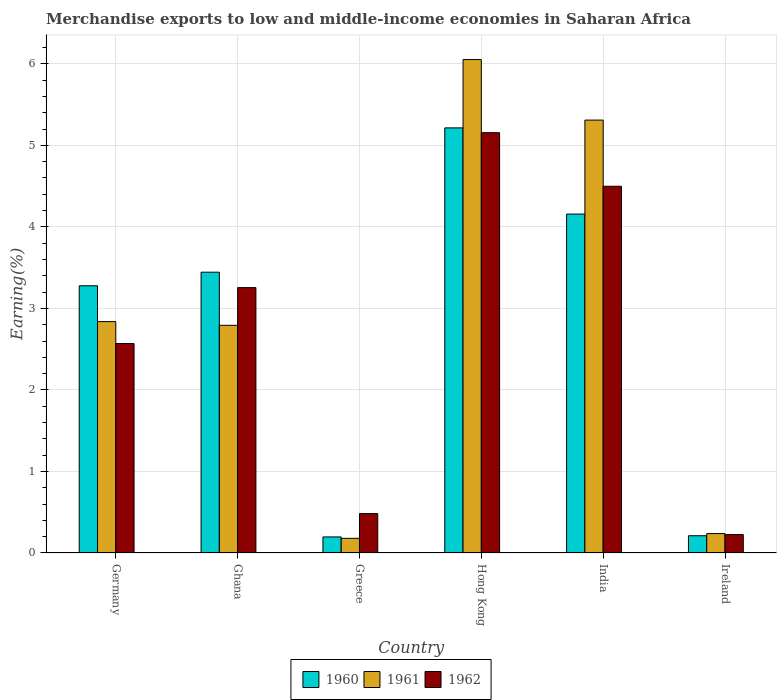How many different coloured bars are there?
Your answer should be compact. 3. How many groups of bars are there?
Ensure brevity in your answer.  6. Are the number of bars per tick equal to the number of legend labels?
Offer a very short reply. Yes. Are the number of bars on each tick of the X-axis equal?
Ensure brevity in your answer.  Yes. What is the label of the 3rd group of bars from the left?
Give a very brief answer. Greece. In how many cases, is the number of bars for a given country not equal to the number of legend labels?
Your response must be concise. 0. What is the percentage of amount earned from merchandise exports in 1961 in Ireland?
Make the answer very short. 0.24. Across all countries, what is the maximum percentage of amount earned from merchandise exports in 1960?
Provide a succinct answer. 5.21. Across all countries, what is the minimum percentage of amount earned from merchandise exports in 1961?
Keep it short and to the point. 0.18. In which country was the percentage of amount earned from merchandise exports in 1962 maximum?
Offer a terse response. Hong Kong. In which country was the percentage of amount earned from merchandise exports in 1962 minimum?
Keep it short and to the point. Ireland. What is the total percentage of amount earned from merchandise exports in 1960 in the graph?
Your answer should be compact. 16.5. What is the difference between the percentage of amount earned from merchandise exports in 1961 in Germany and that in Greece?
Your response must be concise. 2.66. What is the difference between the percentage of amount earned from merchandise exports in 1961 in India and the percentage of amount earned from merchandise exports in 1962 in Ghana?
Offer a very short reply. 2.05. What is the average percentage of amount earned from merchandise exports in 1960 per country?
Ensure brevity in your answer.  2.75. What is the difference between the percentage of amount earned from merchandise exports of/in 1960 and percentage of amount earned from merchandise exports of/in 1961 in Ireland?
Your answer should be very brief. -0.03. In how many countries, is the percentage of amount earned from merchandise exports in 1961 greater than 1.2 %?
Your answer should be very brief. 4. What is the ratio of the percentage of amount earned from merchandise exports in 1962 in Germany to that in India?
Make the answer very short. 0.57. Is the percentage of amount earned from merchandise exports in 1961 in Hong Kong less than that in India?
Your response must be concise. No. Is the difference between the percentage of amount earned from merchandise exports in 1960 in Greece and Ireland greater than the difference between the percentage of amount earned from merchandise exports in 1961 in Greece and Ireland?
Offer a very short reply. Yes. What is the difference between the highest and the second highest percentage of amount earned from merchandise exports in 1962?
Make the answer very short. -1.24. What is the difference between the highest and the lowest percentage of amount earned from merchandise exports in 1960?
Your answer should be very brief. 5.02. Is the sum of the percentage of amount earned from merchandise exports in 1961 in Ghana and India greater than the maximum percentage of amount earned from merchandise exports in 1960 across all countries?
Offer a very short reply. Yes. What does the 3rd bar from the left in Greece represents?
Make the answer very short. 1962. What does the 1st bar from the right in Hong Kong represents?
Ensure brevity in your answer.  1962. How many bars are there?
Keep it short and to the point. 18. What is the difference between two consecutive major ticks on the Y-axis?
Provide a succinct answer. 1. Does the graph contain any zero values?
Your response must be concise. No. How many legend labels are there?
Ensure brevity in your answer.  3. What is the title of the graph?
Your answer should be very brief. Merchandise exports to low and middle-income economies in Saharan Africa. Does "1966" appear as one of the legend labels in the graph?
Keep it short and to the point. No. What is the label or title of the X-axis?
Give a very brief answer. Country. What is the label or title of the Y-axis?
Give a very brief answer. Earning(%). What is the Earning(%) in 1960 in Germany?
Offer a very short reply. 3.28. What is the Earning(%) in 1961 in Germany?
Your answer should be very brief. 2.84. What is the Earning(%) of 1962 in Germany?
Give a very brief answer. 2.57. What is the Earning(%) in 1960 in Ghana?
Provide a succinct answer. 3.44. What is the Earning(%) of 1961 in Ghana?
Offer a terse response. 2.79. What is the Earning(%) in 1962 in Ghana?
Make the answer very short. 3.25. What is the Earning(%) in 1960 in Greece?
Provide a succinct answer. 0.2. What is the Earning(%) in 1961 in Greece?
Your answer should be compact. 0.18. What is the Earning(%) in 1962 in Greece?
Give a very brief answer. 0.48. What is the Earning(%) in 1960 in Hong Kong?
Your answer should be very brief. 5.21. What is the Earning(%) of 1961 in Hong Kong?
Keep it short and to the point. 6.05. What is the Earning(%) of 1962 in Hong Kong?
Ensure brevity in your answer.  5.16. What is the Earning(%) of 1960 in India?
Your response must be concise. 4.16. What is the Earning(%) of 1961 in India?
Keep it short and to the point. 5.31. What is the Earning(%) in 1962 in India?
Offer a very short reply. 4.5. What is the Earning(%) of 1960 in Ireland?
Keep it short and to the point. 0.21. What is the Earning(%) of 1961 in Ireland?
Ensure brevity in your answer.  0.24. What is the Earning(%) in 1962 in Ireland?
Your response must be concise. 0.23. Across all countries, what is the maximum Earning(%) in 1960?
Your response must be concise. 5.21. Across all countries, what is the maximum Earning(%) of 1961?
Make the answer very short. 6.05. Across all countries, what is the maximum Earning(%) of 1962?
Provide a succinct answer. 5.16. Across all countries, what is the minimum Earning(%) of 1960?
Offer a terse response. 0.2. Across all countries, what is the minimum Earning(%) of 1961?
Provide a short and direct response. 0.18. Across all countries, what is the minimum Earning(%) in 1962?
Keep it short and to the point. 0.23. What is the total Earning(%) in 1960 in the graph?
Provide a short and direct response. 16.5. What is the total Earning(%) in 1961 in the graph?
Ensure brevity in your answer.  17.41. What is the total Earning(%) in 1962 in the graph?
Your response must be concise. 16.19. What is the difference between the Earning(%) in 1960 in Germany and that in Ghana?
Your answer should be very brief. -0.17. What is the difference between the Earning(%) in 1961 in Germany and that in Ghana?
Ensure brevity in your answer.  0.05. What is the difference between the Earning(%) of 1962 in Germany and that in Ghana?
Offer a very short reply. -0.69. What is the difference between the Earning(%) in 1960 in Germany and that in Greece?
Provide a short and direct response. 3.08. What is the difference between the Earning(%) of 1961 in Germany and that in Greece?
Provide a short and direct response. 2.66. What is the difference between the Earning(%) in 1962 in Germany and that in Greece?
Keep it short and to the point. 2.09. What is the difference between the Earning(%) of 1960 in Germany and that in Hong Kong?
Your response must be concise. -1.94. What is the difference between the Earning(%) in 1961 in Germany and that in Hong Kong?
Your answer should be compact. -3.21. What is the difference between the Earning(%) in 1962 in Germany and that in Hong Kong?
Your answer should be compact. -2.59. What is the difference between the Earning(%) in 1960 in Germany and that in India?
Ensure brevity in your answer.  -0.88. What is the difference between the Earning(%) in 1961 in Germany and that in India?
Offer a terse response. -2.47. What is the difference between the Earning(%) of 1962 in Germany and that in India?
Provide a short and direct response. -1.93. What is the difference between the Earning(%) of 1960 in Germany and that in Ireland?
Give a very brief answer. 3.07. What is the difference between the Earning(%) of 1961 in Germany and that in Ireland?
Give a very brief answer. 2.6. What is the difference between the Earning(%) in 1962 in Germany and that in Ireland?
Your answer should be very brief. 2.34. What is the difference between the Earning(%) of 1960 in Ghana and that in Greece?
Ensure brevity in your answer.  3.25. What is the difference between the Earning(%) in 1961 in Ghana and that in Greece?
Offer a terse response. 2.61. What is the difference between the Earning(%) of 1962 in Ghana and that in Greece?
Your answer should be compact. 2.77. What is the difference between the Earning(%) in 1960 in Ghana and that in Hong Kong?
Your response must be concise. -1.77. What is the difference between the Earning(%) of 1961 in Ghana and that in Hong Kong?
Give a very brief answer. -3.26. What is the difference between the Earning(%) in 1962 in Ghana and that in Hong Kong?
Provide a short and direct response. -1.9. What is the difference between the Earning(%) of 1960 in Ghana and that in India?
Offer a very short reply. -0.71. What is the difference between the Earning(%) in 1961 in Ghana and that in India?
Provide a succinct answer. -2.52. What is the difference between the Earning(%) of 1962 in Ghana and that in India?
Offer a very short reply. -1.24. What is the difference between the Earning(%) in 1960 in Ghana and that in Ireland?
Your answer should be compact. 3.23. What is the difference between the Earning(%) of 1961 in Ghana and that in Ireland?
Offer a very short reply. 2.55. What is the difference between the Earning(%) in 1962 in Ghana and that in Ireland?
Provide a short and direct response. 3.03. What is the difference between the Earning(%) of 1960 in Greece and that in Hong Kong?
Your answer should be very brief. -5.02. What is the difference between the Earning(%) in 1961 in Greece and that in Hong Kong?
Your answer should be compact. -5.87. What is the difference between the Earning(%) in 1962 in Greece and that in Hong Kong?
Your answer should be compact. -4.67. What is the difference between the Earning(%) of 1960 in Greece and that in India?
Provide a succinct answer. -3.96. What is the difference between the Earning(%) of 1961 in Greece and that in India?
Offer a terse response. -5.13. What is the difference between the Earning(%) of 1962 in Greece and that in India?
Ensure brevity in your answer.  -4.01. What is the difference between the Earning(%) in 1960 in Greece and that in Ireland?
Give a very brief answer. -0.01. What is the difference between the Earning(%) in 1961 in Greece and that in Ireland?
Your answer should be compact. -0.06. What is the difference between the Earning(%) of 1962 in Greece and that in Ireland?
Ensure brevity in your answer.  0.26. What is the difference between the Earning(%) of 1960 in Hong Kong and that in India?
Offer a very short reply. 1.06. What is the difference between the Earning(%) of 1961 in Hong Kong and that in India?
Provide a succinct answer. 0.74. What is the difference between the Earning(%) of 1962 in Hong Kong and that in India?
Offer a very short reply. 0.66. What is the difference between the Earning(%) in 1960 in Hong Kong and that in Ireland?
Your answer should be compact. 5. What is the difference between the Earning(%) in 1961 in Hong Kong and that in Ireland?
Make the answer very short. 5.81. What is the difference between the Earning(%) in 1962 in Hong Kong and that in Ireland?
Provide a succinct answer. 4.93. What is the difference between the Earning(%) in 1960 in India and that in Ireland?
Provide a succinct answer. 3.95. What is the difference between the Earning(%) of 1961 in India and that in Ireland?
Your answer should be very brief. 5.07. What is the difference between the Earning(%) of 1962 in India and that in Ireland?
Make the answer very short. 4.27. What is the difference between the Earning(%) in 1960 in Germany and the Earning(%) in 1961 in Ghana?
Provide a short and direct response. 0.48. What is the difference between the Earning(%) of 1960 in Germany and the Earning(%) of 1962 in Ghana?
Your answer should be very brief. 0.02. What is the difference between the Earning(%) of 1961 in Germany and the Earning(%) of 1962 in Ghana?
Provide a succinct answer. -0.42. What is the difference between the Earning(%) of 1960 in Germany and the Earning(%) of 1961 in Greece?
Your answer should be very brief. 3.1. What is the difference between the Earning(%) in 1960 in Germany and the Earning(%) in 1962 in Greece?
Ensure brevity in your answer.  2.79. What is the difference between the Earning(%) of 1961 in Germany and the Earning(%) of 1962 in Greece?
Provide a short and direct response. 2.35. What is the difference between the Earning(%) of 1960 in Germany and the Earning(%) of 1961 in Hong Kong?
Ensure brevity in your answer.  -2.77. What is the difference between the Earning(%) of 1960 in Germany and the Earning(%) of 1962 in Hong Kong?
Offer a terse response. -1.88. What is the difference between the Earning(%) of 1961 in Germany and the Earning(%) of 1962 in Hong Kong?
Make the answer very short. -2.32. What is the difference between the Earning(%) of 1960 in Germany and the Earning(%) of 1961 in India?
Give a very brief answer. -2.03. What is the difference between the Earning(%) in 1960 in Germany and the Earning(%) in 1962 in India?
Offer a very short reply. -1.22. What is the difference between the Earning(%) of 1961 in Germany and the Earning(%) of 1962 in India?
Keep it short and to the point. -1.66. What is the difference between the Earning(%) of 1960 in Germany and the Earning(%) of 1961 in Ireland?
Provide a short and direct response. 3.04. What is the difference between the Earning(%) of 1960 in Germany and the Earning(%) of 1962 in Ireland?
Offer a terse response. 3.05. What is the difference between the Earning(%) of 1961 in Germany and the Earning(%) of 1962 in Ireland?
Offer a very short reply. 2.61. What is the difference between the Earning(%) of 1960 in Ghana and the Earning(%) of 1961 in Greece?
Provide a short and direct response. 3.26. What is the difference between the Earning(%) in 1960 in Ghana and the Earning(%) in 1962 in Greece?
Keep it short and to the point. 2.96. What is the difference between the Earning(%) of 1961 in Ghana and the Earning(%) of 1962 in Greece?
Your answer should be compact. 2.31. What is the difference between the Earning(%) in 1960 in Ghana and the Earning(%) in 1961 in Hong Kong?
Make the answer very short. -2.61. What is the difference between the Earning(%) of 1960 in Ghana and the Earning(%) of 1962 in Hong Kong?
Give a very brief answer. -1.71. What is the difference between the Earning(%) of 1961 in Ghana and the Earning(%) of 1962 in Hong Kong?
Your answer should be very brief. -2.36. What is the difference between the Earning(%) of 1960 in Ghana and the Earning(%) of 1961 in India?
Provide a succinct answer. -1.87. What is the difference between the Earning(%) of 1960 in Ghana and the Earning(%) of 1962 in India?
Offer a terse response. -1.05. What is the difference between the Earning(%) of 1961 in Ghana and the Earning(%) of 1962 in India?
Offer a terse response. -1.71. What is the difference between the Earning(%) in 1960 in Ghana and the Earning(%) in 1961 in Ireland?
Keep it short and to the point. 3.21. What is the difference between the Earning(%) in 1960 in Ghana and the Earning(%) in 1962 in Ireland?
Your answer should be very brief. 3.22. What is the difference between the Earning(%) in 1961 in Ghana and the Earning(%) in 1962 in Ireland?
Provide a short and direct response. 2.57. What is the difference between the Earning(%) of 1960 in Greece and the Earning(%) of 1961 in Hong Kong?
Ensure brevity in your answer.  -5.86. What is the difference between the Earning(%) in 1960 in Greece and the Earning(%) in 1962 in Hong Kong?
Provide a succinct answer. -4.96. What is the difference between the Earning(%) in 1961 in Greece and the Earning(%) in 1962 in Hong Kong?
Offer a very short reply. -4.98. What is the difference between the Earning(%) of 1960 in Greece and the Earning(%) of 1961 in India?
Give a very brief answer. -5.11. What is the difference between the Earning(%) in 1960 in Greece and the Earning(%) in 1962 in India?
Your answer should be compact. -4.3. What is the difference between the Earning(%) in 1961 in Greece and the Earning(%) in 1962 in India?
Keep it short and to the point. -4.32. What is the difference between the Earning(%) in 1960 in Greece and the Earning(%) in 1961 in Ireland?
Offer a terse response. -0.04. What is the difference between the Earning(%) in 1960 in Greece and the Earning(%) in 1962 in Ireland?
Offer a terse response. -0.03. What is the difference between the Earning(%) in 1961 in Greece and the Earning(%) in 1962 in Ireland?
Provide a succinct answer. -0.05. What is the difference between the Earning(%) in 1960 in Hong Kong and the Earning(%) in 1961 in India?
Your response must be concise. -0.1. What is the difference between the Earning(%) of 1960 in Hong Kong and the Earning(%) of 1962 in India?
Offer a very short reply. 0.72. What is the difference between the Earning(%) of 1961 in Hong Kong and the Earning(%) of 1962 in India?
Ensure brevity in your answer.  1.55. What is the difference between the Earning(%) of 1960 in Hong Kong and the Earning(%) of 1961 in Ireland?
Provide a succinct answer. 4.98. What is the difference between the Earning(%) of 1960 in Hong Kong and the Earning(%) of 1962 in Ireland?
Provide a short and direct response. 4.99. What is the difference between the Earning(%) in 1961 in Hong Kong and the Earning(%) in 1962 in Ireland?
Ensure brevity in your answer.  5.83. What is the difference between the Earning(%) in 1960 in India and the Earning(%) in 1961 in Ireland?
Keep it short and to the point. 3.92. What is the difference between the Earning(%) in 1960 in India and the Earning(%) in 1962 in Ireland?
Ensure brevity in your answer.  3.93. What is the difference between the Earning(%) of 1961 in India and the Earning(%) of 1962 in Ireland?
Your answer should be compact. 5.08. What is the average Earning(%) of 1960 per country?
Your answer should be compact. 2.75. What is the average Earning(%) in 1961 per country?
Your answer should be compact. 2.9. What is the average Earning(%) of 1962 per country?
Keep it short and to the point. 2.7. What is the difference between the Earning(%) in 1960 and Earning(%) in 1961 in Germany?
Ensure brevity in your answer.  0.44. What is the difference between the Earning(%) in 1960 and Earning(%) in 1962 in Germany?
Provide a short and direct response. 0.71. What is the difference between the Earning(%) of 1961 and Earning(%) of 1962 in Germany?
Your response must be concise. 0.27. What is the difference between the Earning(%) of 1960 and Earning(%) of 1961 in Ghana?
Ensure brevity in your answer.  0.65. What is the difference between the Earning(%) of 1960 and Earning(%) of 1962 in Ghana?
Your answer should be compact. 0.19. What is the difference between the Earning(%) of 1961 and Earning(%) of 1962 in Ghana?
Provide a succinct answer. -0.46. What is the difference between the Earning(%) in 1960 and Earning(%) in 1961 in Greece?
Your answer should be very brief. 0.02. What is the difference between the Earning(%) in 1960 and Earning(%) in 1962 in Greece?
Keep it short and to the point. -0.29. What is the difference between the Earning(%) in 1961 and Earning(%) in 1962 in Greece?
Your answer should be compact. -0.3. What is the difference between the Earning(%) of 1960 and Earning(%) of 1961 in Hong Kong?
Keep it short and to the point. -0.84. What is the difference between the Earning(%) in 1960 and Earning(%) in 1962 in Hong Kong?
Provide a succinct answer. 0.06. What is the difference between the Earning(%) in 1961 and Earning(%) in 1962 in Hong Kong?
Ensure brevity in your answer.  0.9. What is the difference between the Earning(%) of 1960 and Earning(%) of 1961 in India?
Provide a succinct answer. -1.15. What is the difference between the Earning(%) in 1960 and Earning(%) in 1962 in India?
Offer a very short reply. -0.34. What is the difference between the Earning(%) of 1961 and Earning(%) of 1962 in India?
Make the answer very short. 0.81. What is the difference between the Earning(%) in 1960 and Earning(%) in 1961 in Ireland?
Your answer should be compact. -0.03. What is the difference between the Earning(%) in 1960 and Earning(%) in 1962 in Ireland?
Keep it short and to the point. -0.01. What is the difference between the Earning(%) in 1961 and Earning(%) in 1962 in Ireland?
Offer a terse response. 0.01. What is the ratio of the Earning(%) of 1960 in Germany to that in Ghana?
Offer a terse response. 0.95. What is the ratio of the Earning(%) of 1961 in Germany to that in Ghana?
Your answer should be compact. 1.02. What is the ratio of the Earning(%) in 1962 in Germany to that in Ghana?
Give a very brief answer. 0.79. What is the ratio of the Earning(%) of 1960 in Germany to that in Greece?
Your response must be concise. 16.64. What is the ratio of the Earning(%) of 1961 in Germany to that in Greece?
Your response must be concise. 15.79. What is the ratio of the Earning(%) in 1962 in Germany to that in Greece?
Keep it short and to the point. 5.32. What is the ratio of the Earning(%) of 1960 in Germany to that in Hong Kong?
Ensure brevity in your answer.  0.63. What is the ratio of the Earning(%) of 1961 in Germany to that in Hong Kong?
Provide a short and direct response. 0.47. What is the ratio of the Earning(%) of 1962 in Germany to that in Hong Kong?
Ensure brevity in your answer.  0.5. What is the ratio of the Earning(%) in 1960 in Germany to that in India?
Provide a short and direct response. 0.79. What is the ratio of the Earning(%) of 1961 in Germany to that in India?
Keep it short and to the point. 0.53. What is the ratio of the Earning(%) in 1962 in Germany to that in India?
Your answer should be very brief. 0.57. What is the ratio of the Earning(%) of 1960 in Germany to that in Ireland?
Ensure brevity in your answer.  15.49. What is the ratio of the Earning(%) in 1961 in Germany to that in Ireland?
Your answer should be very brief. 11.92. What is the ratio of the Earning(%) in 1962 in Germany to that in Ireland?
Your answer should be compact. 11.36. What is the ratio of the Earning(%) in 1960 in Ghana to that in Greece?
Your answer should be compact. 17.49. What is the ratio of the Earning(%) of 1961 in Ghana to that in Greece?
Keep it short and to the point. 15.53. What is the ratio of the Earning(%) of 1962 in Ghana to that in Greece?
Provide a succinct answer. 6.73. What is the ratio of the Earning(%) of 1960 in Ghana to that in Hong Kong?
Offer a very short reply. 0.66. What is the ratio of the Earning(%) of 1961 in Ghana to that in Hong Kong?
Make the answer very short. 0.46. What is the ratio of the Earning(%) of 1962 in Ghana to that in Hong Kong?
Ensure brevity in your answer.  0.63. What is the ratio of the Earning(%) in 1960 in Ghana to that in India?
Your response must be concise. 0.83. What is the ratio of the Earning(%) of 1961 in Ghana to that in India?
Offer a terse response. 0.53. What is the ratio of the Earning(%) in 1962 in Ghana to that in India?
Your answer should be compact. 0.72. What is the ratio of the Earning(%) in 1960 in Ghana to that in Ireland?
Provide a short and direct response. 16.27. What is the ratio of the Earning(%) in 1961 in Ghana to that in Ireland?
Provide a succinct answer. 11.73. What is the ratio of the Earning(%) of 1962 in Ghana to that in Ireland?
Keep it short and to the point. 14.4. What is the ratio of the Earning(%) of 1960 in Greece to that in Hong Kong?
Give a very brief answer. 0.04. What is the ratio of the Earning(%) of 1961 in Greece to that in Hong Kong?
Provide a succinct answer. 0.03. What is the ratio of the Earning(%) in 1962 in Greece to that in Hong Kong?
Your answer should be very brief. 0.09. What is the ratio of the Earning(%) of 1960 in Greece to that in India?
Give a very brief answer. 0.05. What is the ratio of the Earning(%) in 1961 in Greece to that in India?
Your response must be concise. 0.03. What is the ratio of the Earning(%) in 1962 in Greece to that in India?
Offer a terse response. 0.11. What is the ratio of the Earning(%) of 1960 in Greece to that in Ireland?
Offer a very short reply. 0.93. What is the ratio of the Earning(%) in 1961 in Greece to that in Ireland?
Keep it short and to the point. 0.76. What is the ratio of the Earning(%) in 1962 in Greece to that in Ireland?
Ensure brevity in your answer.  2.14. What is the ratio of the Earning(%) of 1960 in Hong Kong to that in India?
Offer a terse response. 1.25. What is the ratio of the Earning(%) in 1961 in Hong Kong to that in India?
Provide a succinct answer. 1.14. What is the ratio of the Earning(%) of 1962 in Hong Kong to that in India?
Keep it short and to the point. 1.15. What is the ratio of the Earning(%) of 1960 in Hong Kong to that in Ireland?
Provide a succinct answer. 24.64. What is the ratio of the Earning(%) of 1961 in Hong Kong to that in Ireland?
Keep it short and to the point. 25.43. What is the ratio of the Earning(%) in 1962 in Hong Kong to that in Ireland?
Keep it short and to the point. 22.8. What is the ratio of the Earning(%) in 1960 in India to that in Ireland?
Your answer should be very brief. 19.64. What is the ratio of the Earning(%) of 1961 in India to that in Ireland?
Your response must be concise. 22.31. What is the ratio of the Earning(%) in 1962 in India to that in Ireland?
Keep it short and to the point. 19.9. What is the difference between the highest and the second highest Earning(%) of 1960?
Ensure brevity in your answer.  1.06. What is the difference between the highest and the second highest Earning(%) in 1961?
Your response must be concise. 0.74. What is the difference between the highest and the second highest Earning(%) of 1962?
Make the answer very short. 0.66. What is the difference between the highest and the lowest Earning(%) in 1960?
Provide a short and direct response. 5.02. What is the difference between the highest and the lowest Earning(%) of 1961?
Offer a very short reply. 5.87. What is the difference between the highest and the lowest Earning(%) in 1962?
Give a very brief answer. 4.93. 